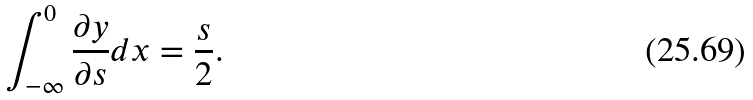<formula> <loc_0><loc_0><loc_500><loc_500>\int _ { - \infty } ^ { 0 } \frac { \partial y } { \partial s } d x = \frac { s } { 2 } .</formula> 